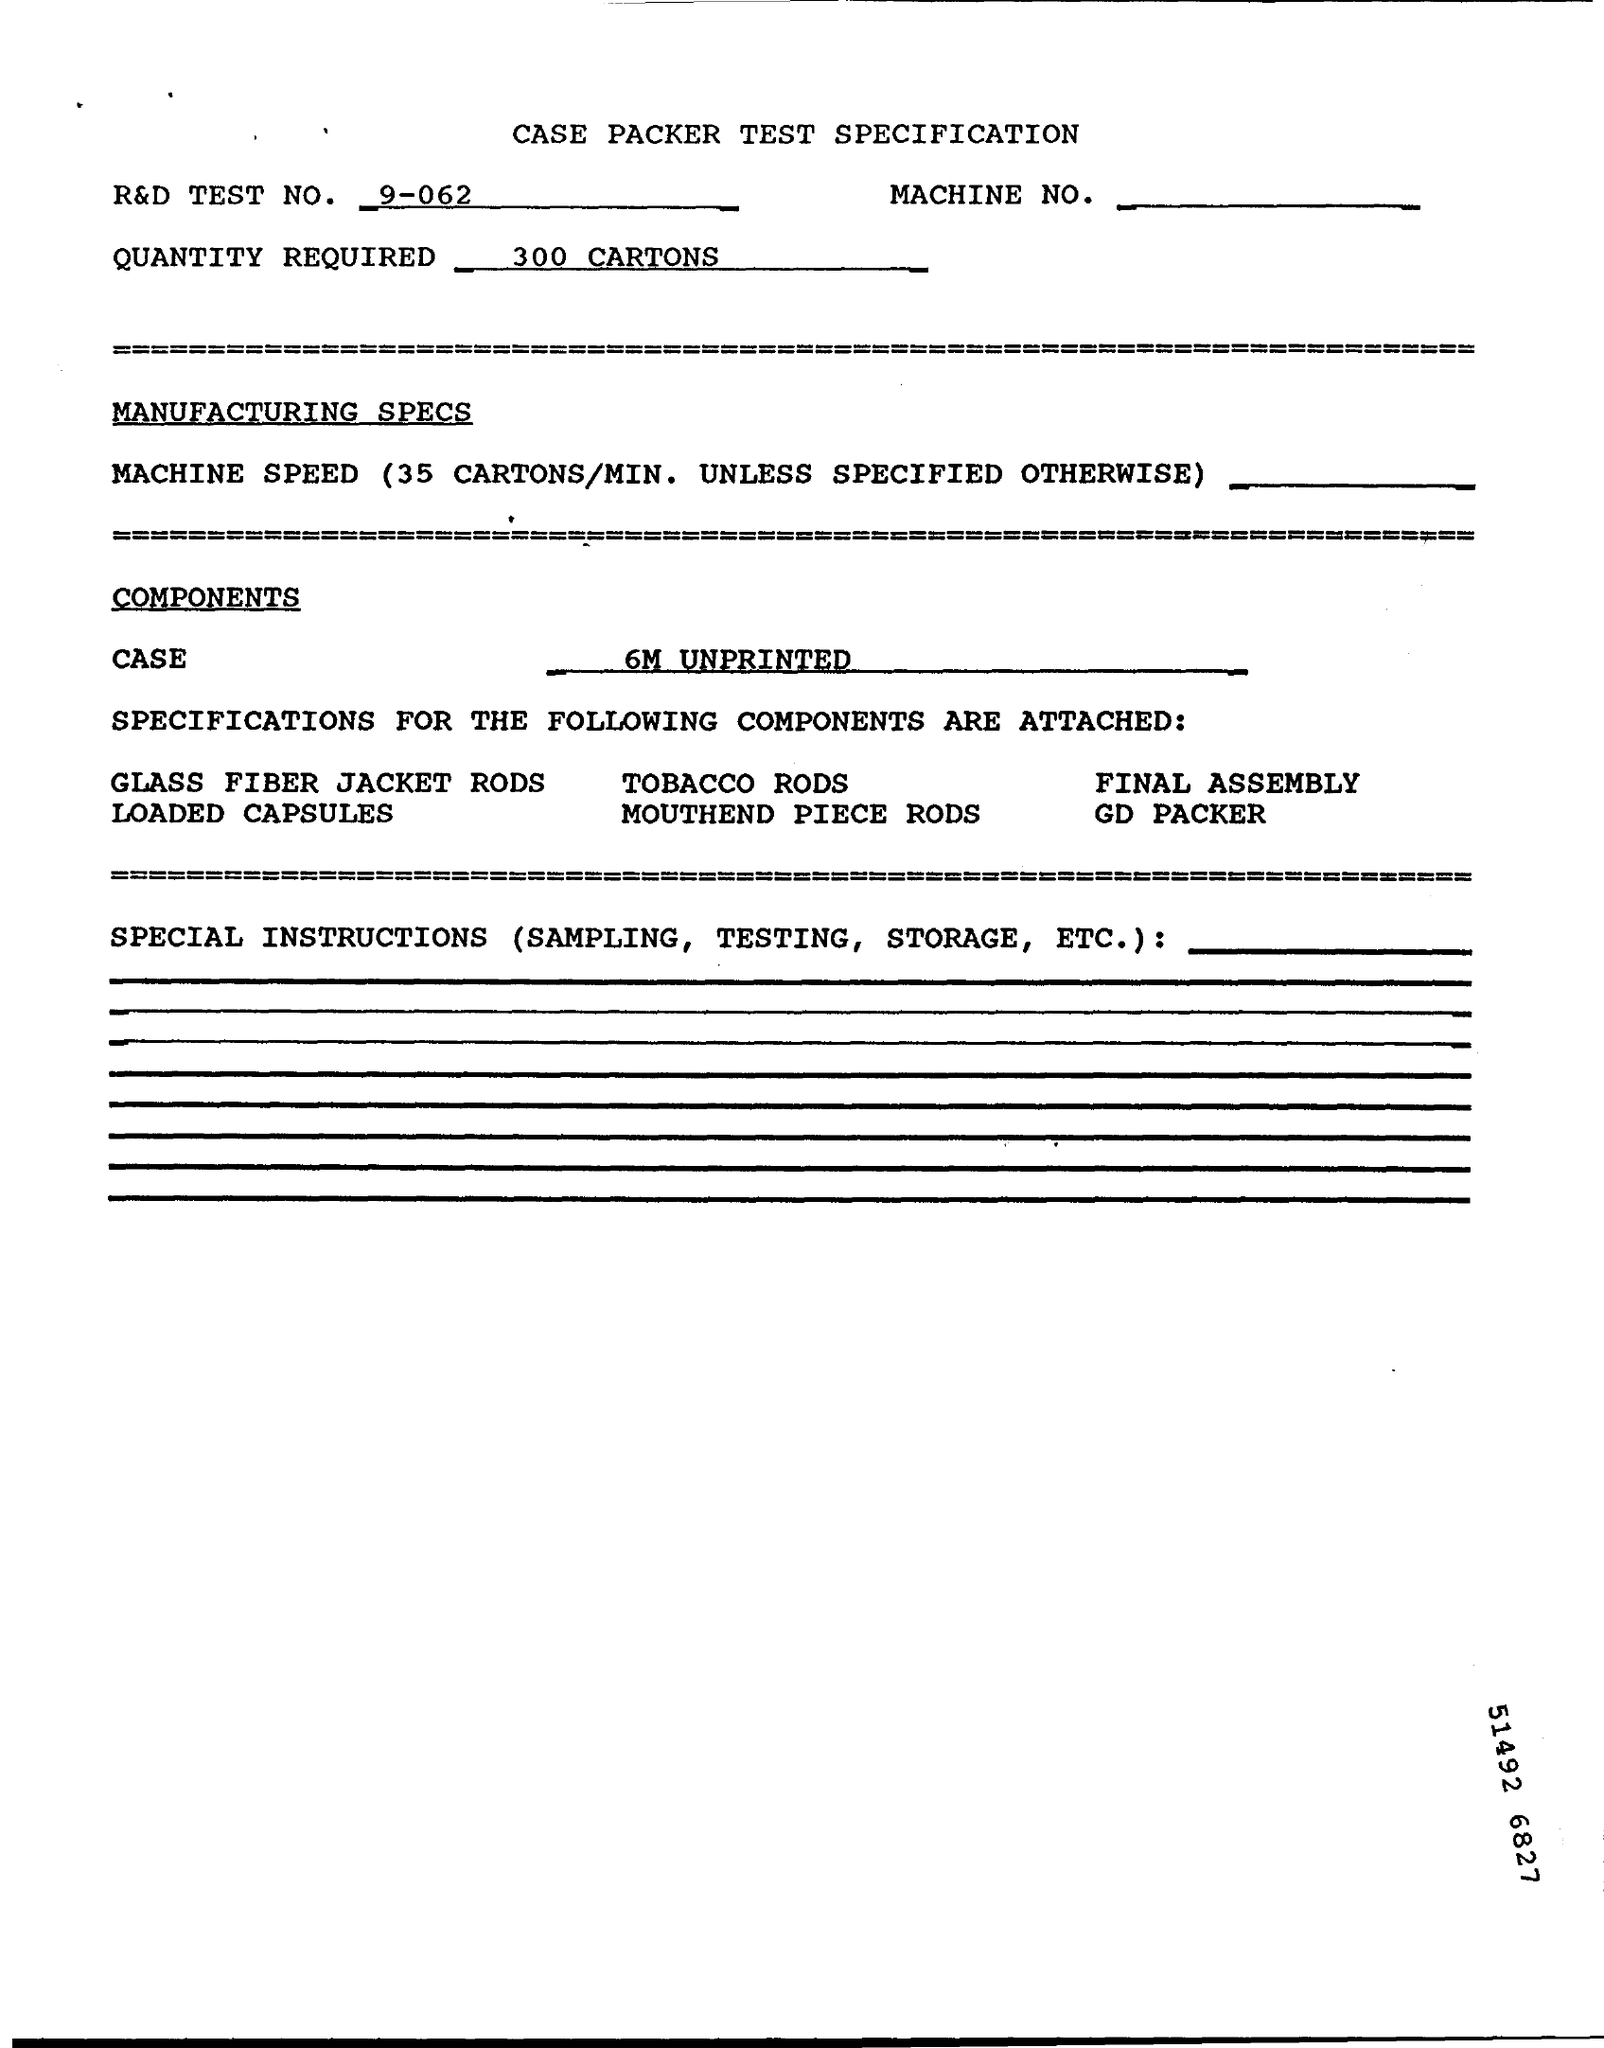Specify some key components in this picture. 300 cartons are required. The R&D Test No. is 9-062... 